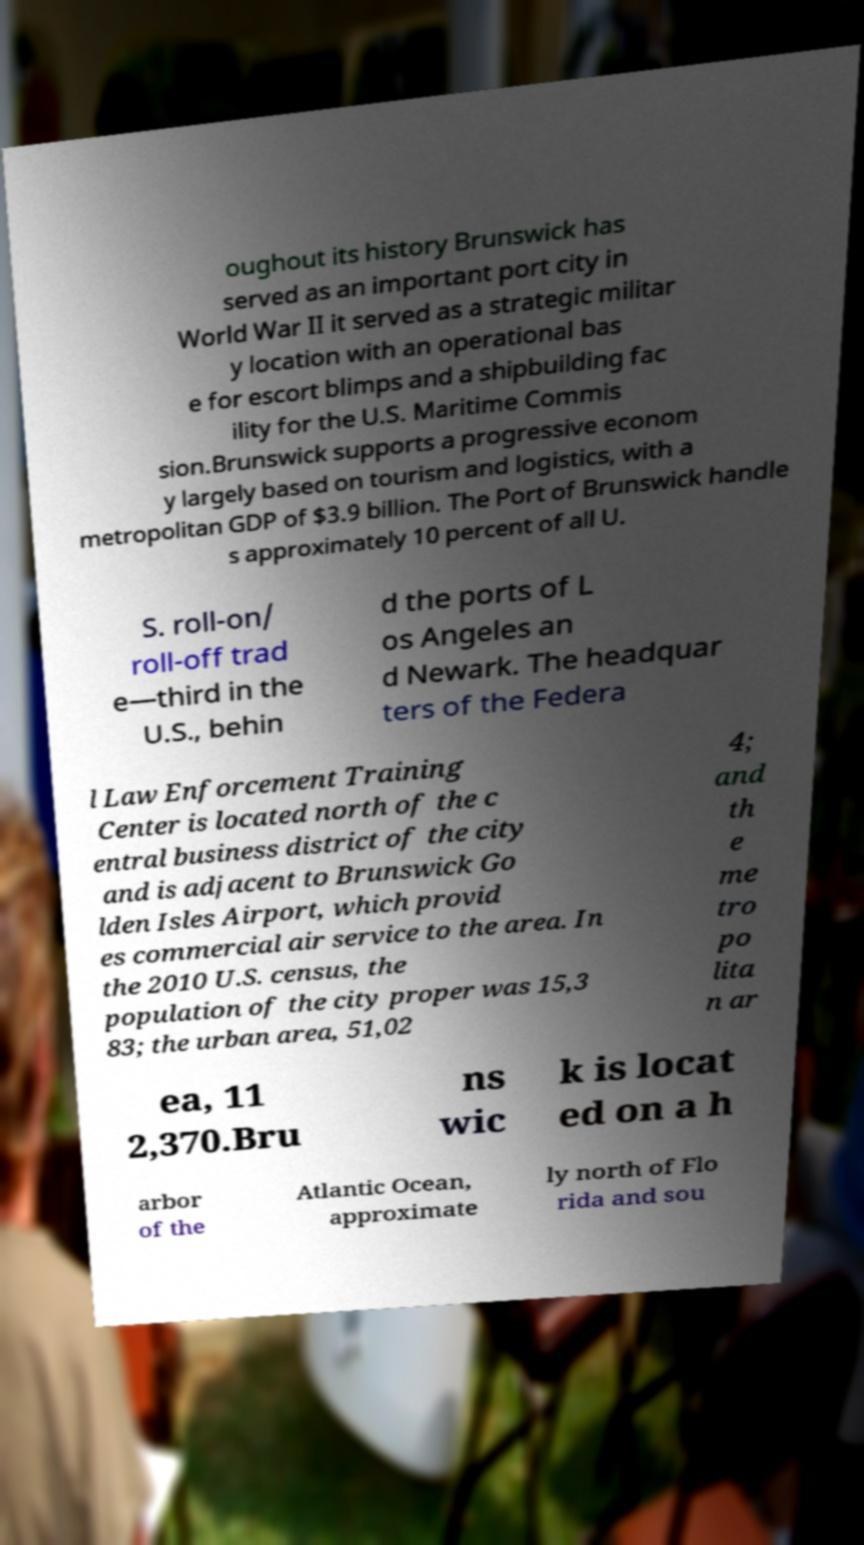For documentation purposes, I need the text within this image transcribed. Could you provide that? oughout its history Brunswick has served as an important port city in World War II it served as a strategic militar y location with an operational bas e for escort blimps and a shipbuilding fac ility for the U.S. Maritime Commis sion.Brunswick supports a progressive econom y largely based on tourism and logistics, with a metropolitan GDP of $3.9 billion. The Port of Brunswick handle s approximately 10 percent of all U. S. roll-on/ roll-off trad e—third in the U.S., behin d the ports of L os Angeles an d Newark. The headquar ters of the Federa l Law Enforcement Training Center is located north of the c entral business district of the city and is adjacent to Brunswick Go lden Isles Airport, which provid es commercial air service to the area. In the 2010 U.S. census, the population of the city proper was 15,3 83; the urban area, 51,02 4; and th e me tro po lita n ar ea, 11 2,370.Bru ns wic k is locat ed on a h arbor of the Atlantic Ocean, approximate ly north of Flo rida and sou 